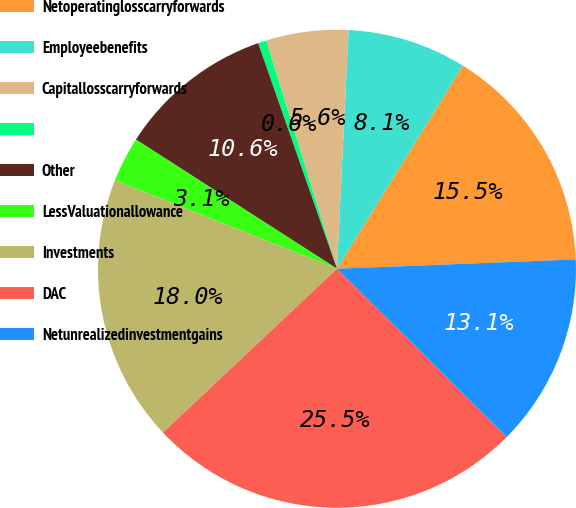<chart> <loc_0><loc_0><loc_500><loc_500><pie_chart><fcel>Netoperatinglosscarryforwards<fcel>Employeebenefits<fcel>Capitallosscarryforwards<fcel>Unnamed: 3<fcel>Other<fcel>LessValuationallowance<fcel>Investments<fcel>DAC<fcel>Netunrealizedinvestmentgains<nl><fcel>15.55%<fcel>8.06%<fcel>5.56%<fcel>0.56%<fcel>10.56%<fcel>3.06%<fcel>18.05%<fcel>25.55%<fcel>13.05%<nl></chart> 